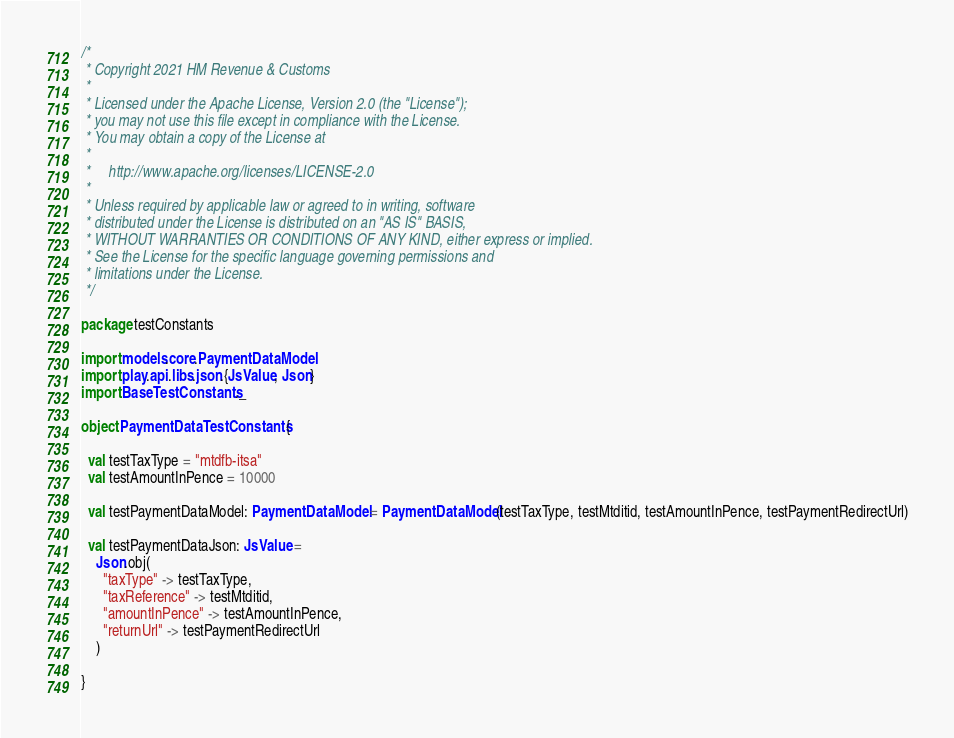<code> <loc_0><loc_0><loc_500><loc_500><_Scala_>/*
 * Copyright 2021 HM Revenue & Customs
 *
 * Licensed under the Apache License, Version 2.0 (the "License");
 * you may not use this file except in compliance with the License.
 * You may obtain a copy of the License at
 *
 *     http://www.apache.org/licenses/LICENSE-2.0
 *
 * Unless required by applicable law or agreed to in writing, software
 * distributed under the License is distributed on an "AS IS" BASIS,
 * WITHOUT WARRANTIES OR CONDITIONS OF ANY KIND, either express or implied.
 * See the License for the specific language governing permissions and
 * limitations under the License.
 */

package testConstants

import models.core.PaymentDataModel
import play.api.libs.json.{JsValue, Json}
import BaseTestConstants._

object PaymentDataTestConstants {

  val testTaxType = "mtdfb-itsa"
  val testAmountInPence = 10000

  val testPaymentDataModel: PaymentDataModel = PaymentDataModel(testTaxType, testMtditid, testAmountInPence, testPaymentRedirectUrl)

  val testPaymentDataJson: JsValue =
    Json.obj(
      "taxType" -> testTaxType,
      "taxReference" -> testMtditid,
      "amountInPence" -> testAmountInPence,
      "returnUrl" -> testPaymentRedirectUrl
    )

}
</code> 